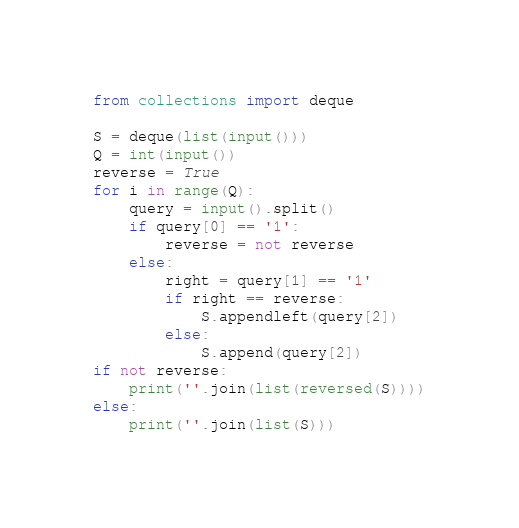<code> <loc_0><loc_0><loc_500><loc_500><_Python_>from collections import deque

S = deque(list(input()))
Q = int(input())
reverse = True
for i in range(Q):
    query = input().split()
    if query[0] == '1':
        reverse = not reverse
    else:
        right = query[1] == '1'
        if right == reverse:
            S.appendleft(query[2])
        else:
            S.append(query[2])
if not reverse:
    print(''.join(list(reversed(S))))
else:
    print(''.join(list(S)))
</code> 